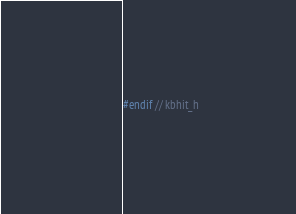Convert code to text. <code><loc_0><loc_0><loc_500><loc_500><_C_>
#endif // kbhit_h
</code> 